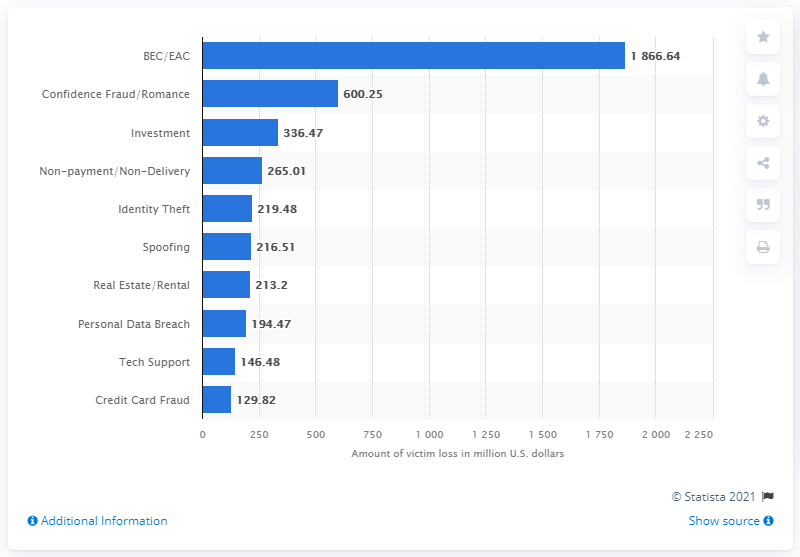Outline some significant characteristics in this image. In 2020, identity theft victims reported a total of 219.48 dollars in losses. In 2020, online confidence fraud and romance scams resulted in an estimated $600.25 million in victim losses due to these types of scams. 